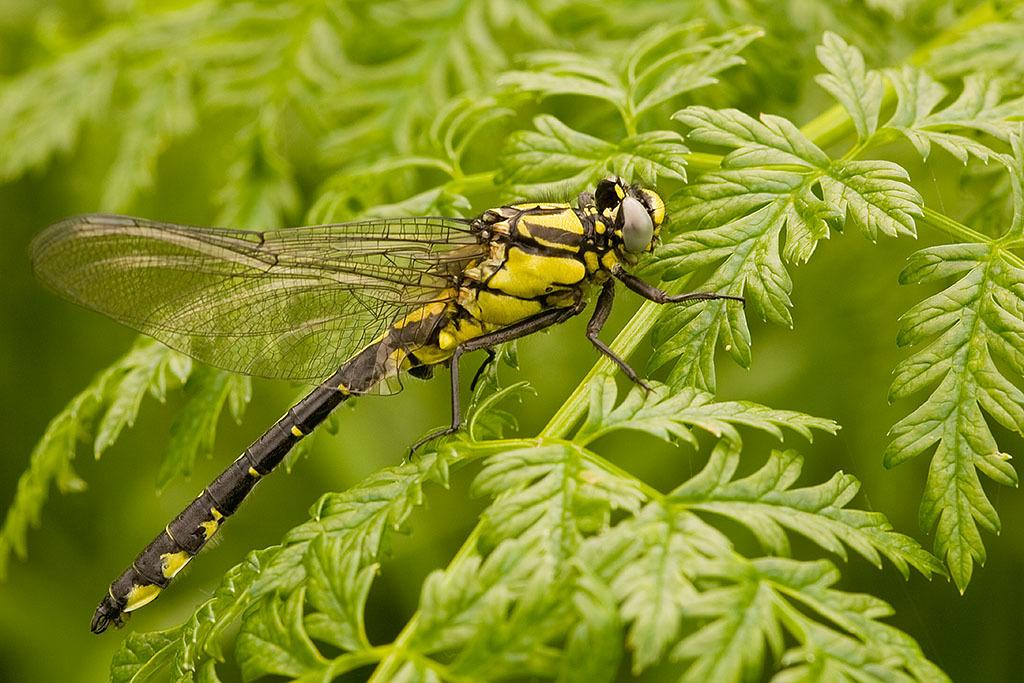What type of vegetation is present in the image? There are leaves in the image. What can be seen in the middle of the image? There is a dragonfly in the middle of the image. Where is the kitty playing with the beam in the image? There is no kitty or beam present in the image; it only features leaves and a dragonfly. 